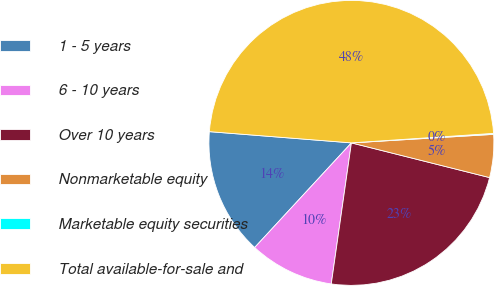Convert chart to OTSL. <chart><loc_0><loc_0><loc_500><loc_500><pie_chart><fcel>1 - 5 years<fcel>6 - 10 years<fcel>Over 10 years<fcel>Nonmarketable equity<fcel>Marketable equity securities<fcel>Total available-for-sale and<nl><fcel>14.38%<fcel>9.62%<fcel>23.34%<fcel>4.87%<fcel>0.11%<fcel>47.68%<nl></chart> 